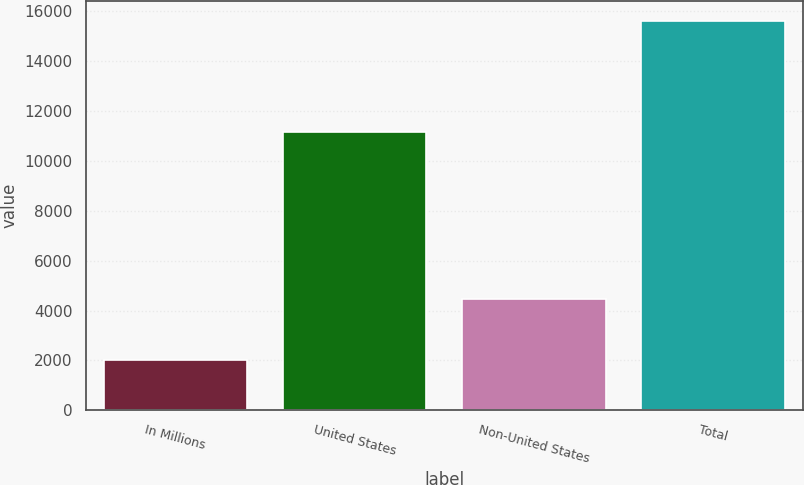<chart> <loc_0><loc_0><loc_500><loc_500><bar_chart><fcel>In Millions<fcel>United States<fcel>Non-United States<fcel>Total<nl><fcel>2017<fcel>11160.9<fcel>4458.9<fcel>15619.8<nl></chart> 